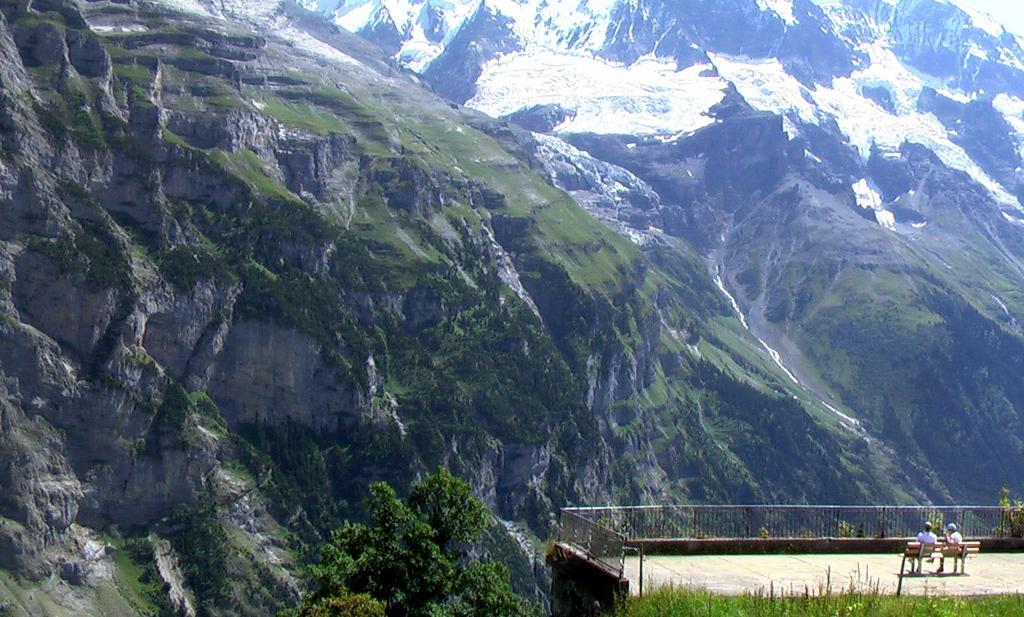How would you summarize this image in a sentence or two? In this image there are two people sitting on the bench, in front of them there is a railing, there are trees, grass and mountains. 